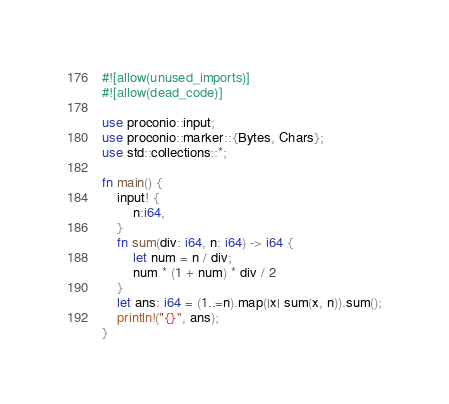Convert code to text. <code><loc_0><loc_0><loc_500><loc_500><_Rust_>#![allow(unused_imports)]
#![allow(dead_code)]

use proconio::input;
use proconio::marker::{Bytes, Chars};
use std::collections::*;

fn main() {
    input! {
        n:i64,
    }
    fn sum(div: i64, n: i64) -> i64 {
        let num = n / div;
        num * (1 + num) * div / 2
    }
    let ans: i64 = (1..=n).map(|x| sum(x, n)).sum();
    println!("{}", ans);
}</code> 